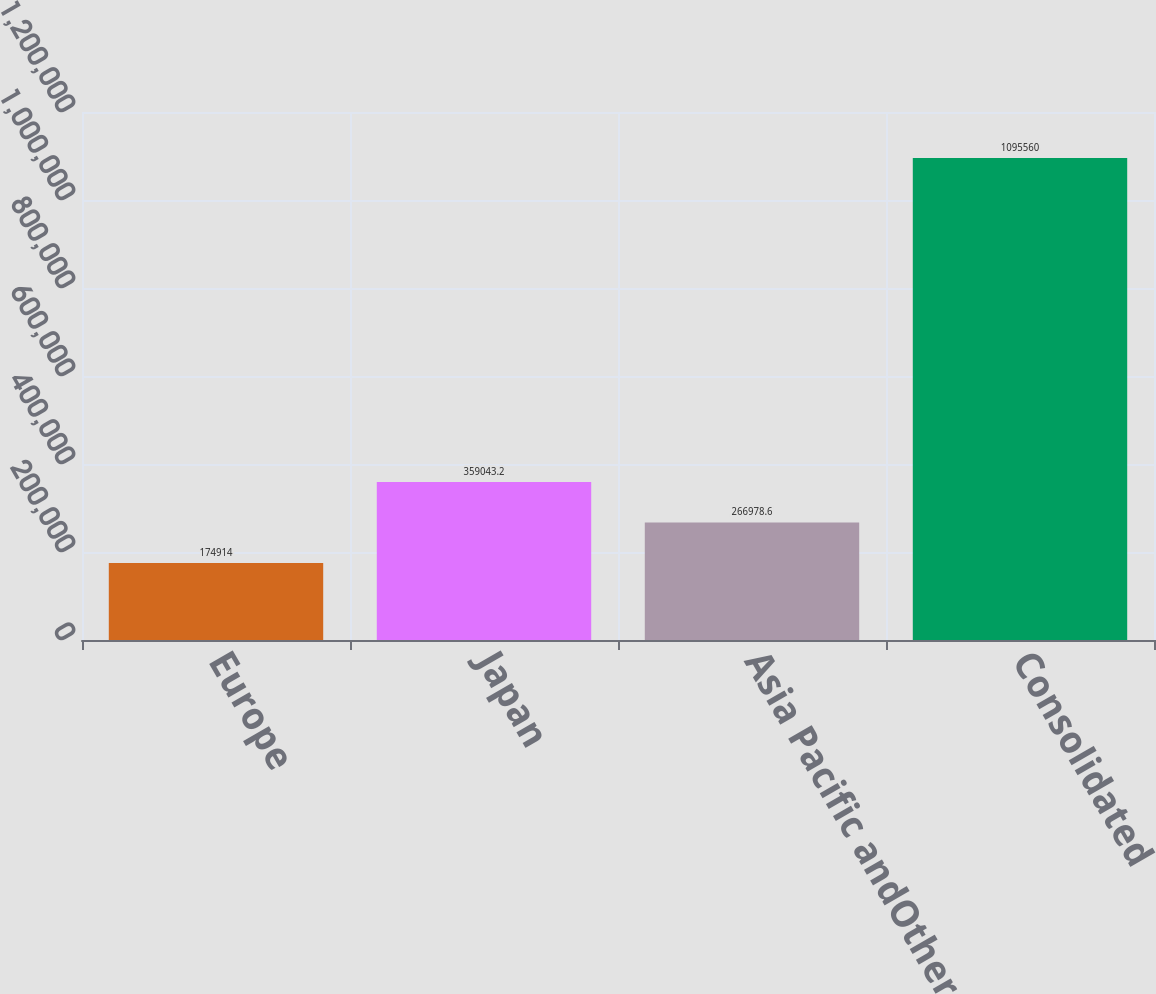Convert chart to OTSL. <chart><loc_0><loc_0><loc_500><loc_500><bar_chart><fcel>Europe<fcel>Japan<fcel>Asia Pacific andOther<fcel>Consolidated<nl><fcel>174914<fcel>359043<fcel>266979<fcel>1.09556e+06<nl></chart> 